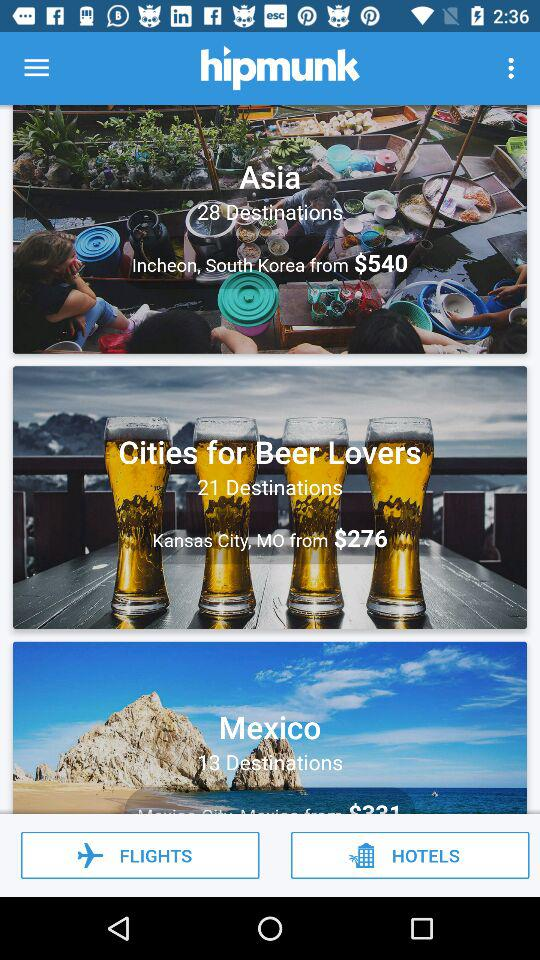How much for the destinations in Mexico?
When the provided information is insufficient, respond with <no answer>. <no answer> 